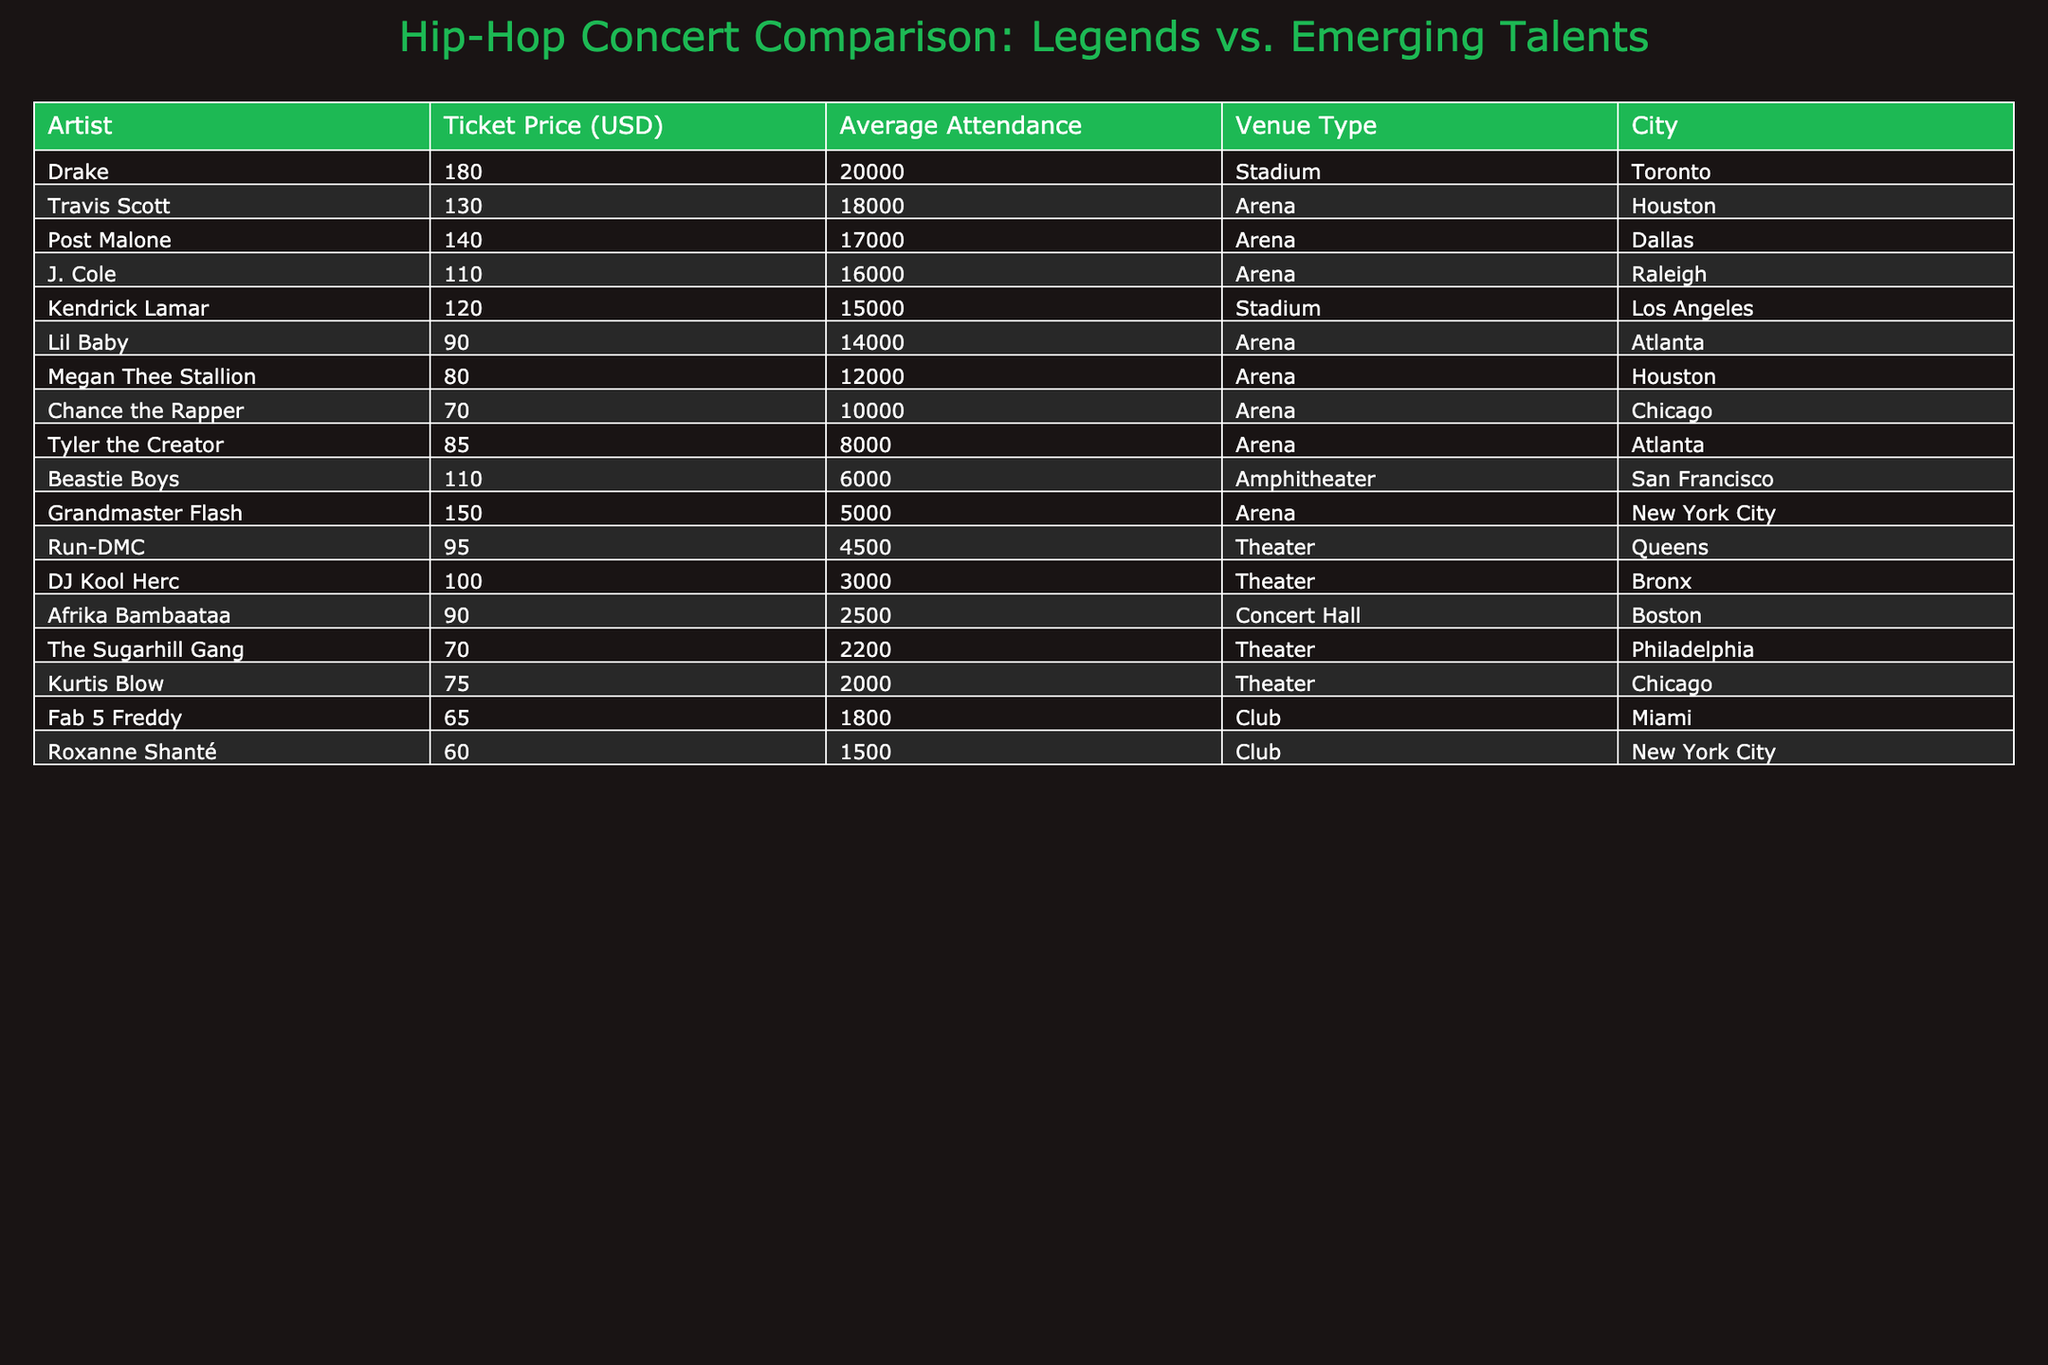What is the highest ticket price among legendary artists? The ticket prices for legendary artists in the table are as follows: Grandmaster Flash at 150, DJ Kool Herc at 100, Afrika Bambaataa at 90, and others. The highest value among these is 150 for Grandmaster Flash.
Answer: 150 Which artist has the lowest average attendance? Looking at the average attendance values listed, DJ Kool Herc has 3000, Afrika Bambaataa has 2500, and Roxanne Shanté has 1500. The lowest attendance is 1500 for Roxanne Shanté.
Answer: 1500 What is the difference in ticket prices between Kendrick Lamar and Drake? Kendrick Lamar's ticket price is 120, while Drake's is 180. The difference is calculated as 180 - 120 = 60.
Answer: 60 Is Megan Thee Stallion's ticket price lower than Tyler the Creator's? Megan Thee Stallion's ticket price is 80, while Tyler the Creator's is 85. Since 80 is less than 85, the statement is true.
Answer: Yes What is the total average attendance for the artists from New York City? The artists from New York City are Grandmaster Flash with 5000 and Roxanne Shanté with 1500. The total average attendance is 5000 + 1500 = 6500.
Answer: 6500 What is the average ticket price for emerging talents? The emerging talents' ticket prices are 90 (Lil Baby), 80 (Megan Thee Stallion), 70 (Chance the Rapper), 65 (Fab 5 Freddy), and 60 (Roxanne Shanté). Adding these gives a total of 90 + 80 + 70 + 65 + 60 = 365. There are 5 artists, so the average is 365 / 5 = 73.
Answer: 73 Is the average attendance for the legendary artists greater than 10,000? The average attendances for legendary artists are 5000 (Grandmaster Flash), 3000 (DJ Kool Herc), 15000 (Kendrick Lamar), 20000 (Drake), 4500 (Run-DMC), and so forth. Adding them would show that the average is below 10,000, since the maximum from the data is only 20000 which is skewed.
Answer: No Which artist has the highest attendance while also having a ticket price under 100? Looking at the ticket prices under 100, we have Afrika Bambaataa (2500), Kurtis Blow (2000), and Roxanne Shanté (1500). The highest attendance among these is 2500 for Afrika Bambaataa.
Answer: Afrika Bambaataa What is the average ticket price among all artists? To calculate the average ticket price, we sum all the ticket prices: 150 + 120 + 100 + 180 + 90 + 85 + 75 + 130 + 110 + 70 + 95 + 80 + 65 + 90 + 140 = 1410. With 15 artists, the average is 1410 / 15 = 94.
Answer: 94 